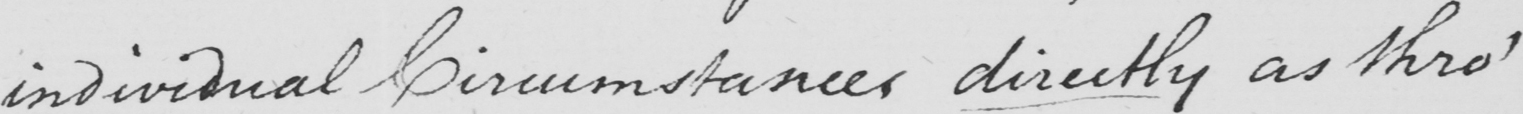Can you tell me what this handwritten text says? individual Circumstances directly as thro' 